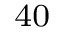Convert formula to latex. <formula><loc_0><loc_0><loc_500><loc_500>^ { 4 0 }</formula> 